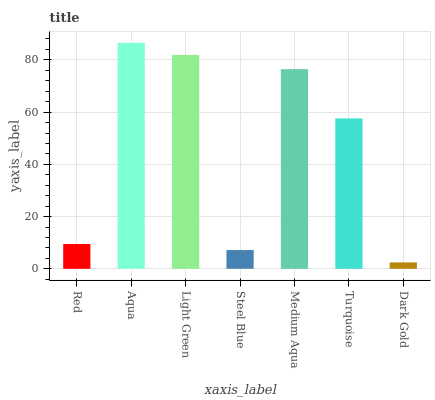Is Dark Gold the minimum?
Answer yes or no. Yes. Is Aqua the maximum?
Answer yes or no. Yes. Is Light Green the minimum?
Answer yes or no. No. Is Light Green the maximum?
Answer yes or no. No. Is Aqua greater than Light Green?
Answer yes or no. Yes. Is Light Green less than Aqua?
Answer yes or no. Yes. Is Light Green greater than Aqua?
Answer yes or no. No. Is Aqua less than Light Green?
Answer yes or no. No. Is Turquoise the high median?
Answer yes or no. Yes. Is Turquoise the low median?
Answer yes or no. Yes. Is Light Green the high median?
Answer yes or no. No. Is Light Green the low median?
Answer yes or no. No. 